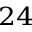Convert formula to latex. <formula><loc_0><loc_0><loc_500><loc_500>^ { 2 4 }</formula> 